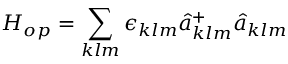Convert formula to latex. <formula><loc_0><loc_0><loc_500><loc_500>H _ { o p } = \sum _ { k l m } \epsilon _ { k l m } \hat { a } _ { k l m } ^ { + } \hat { a } _ { k l m }</formula> 